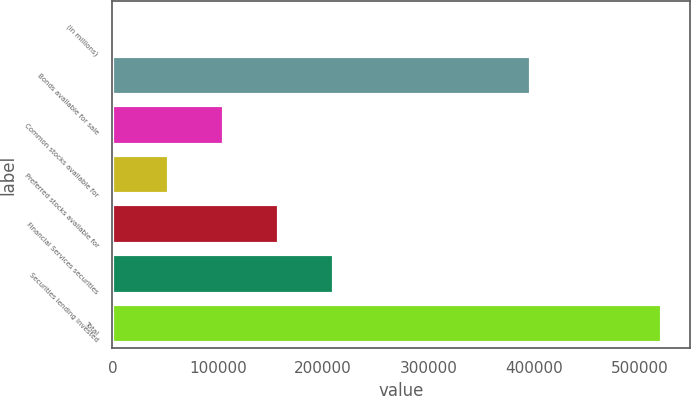Convert chart to OTSL. <chart><loc_0><loc_0><loc_500><loc_500><bar_chart><fcel>(in millions)<fcel>Bonds available for sale<fcel>Common stocks available for<fcel>Preferred stocks available for<fcel>Financial Services securities<fcel>Securities lending invested<fcel>Total<nl><fcel>2007<fcel>397372<fcel>105925<fcel>53965.9<fcel>157884<fcel>209843<fcel>521596<nl></chart> 